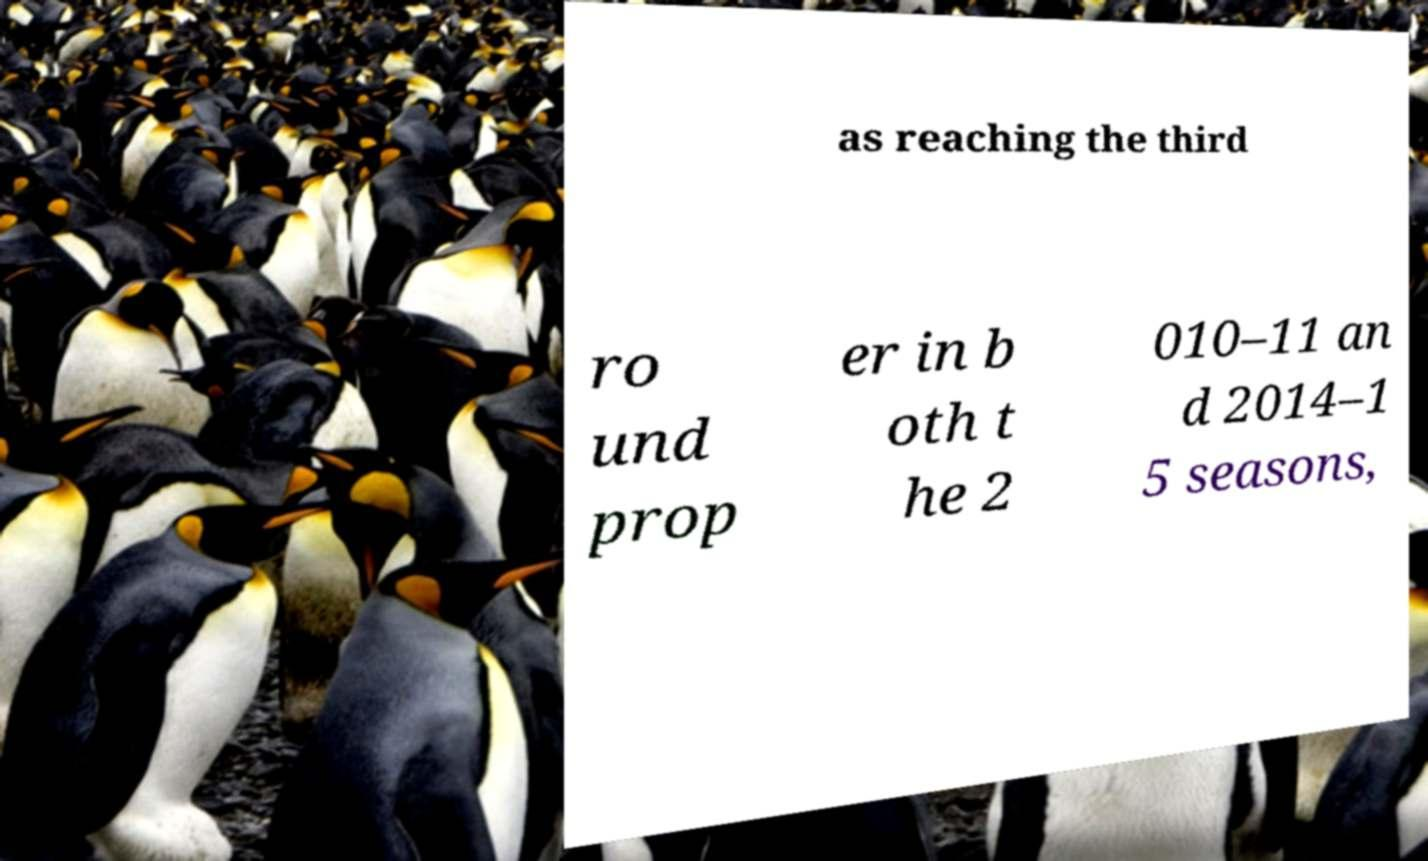Could you assist in decoding the text presented in this image and type it out clearly? as reaching the third ro und prop er in b oth t he 2 010–11 an d 2014–1 5 seasons, 